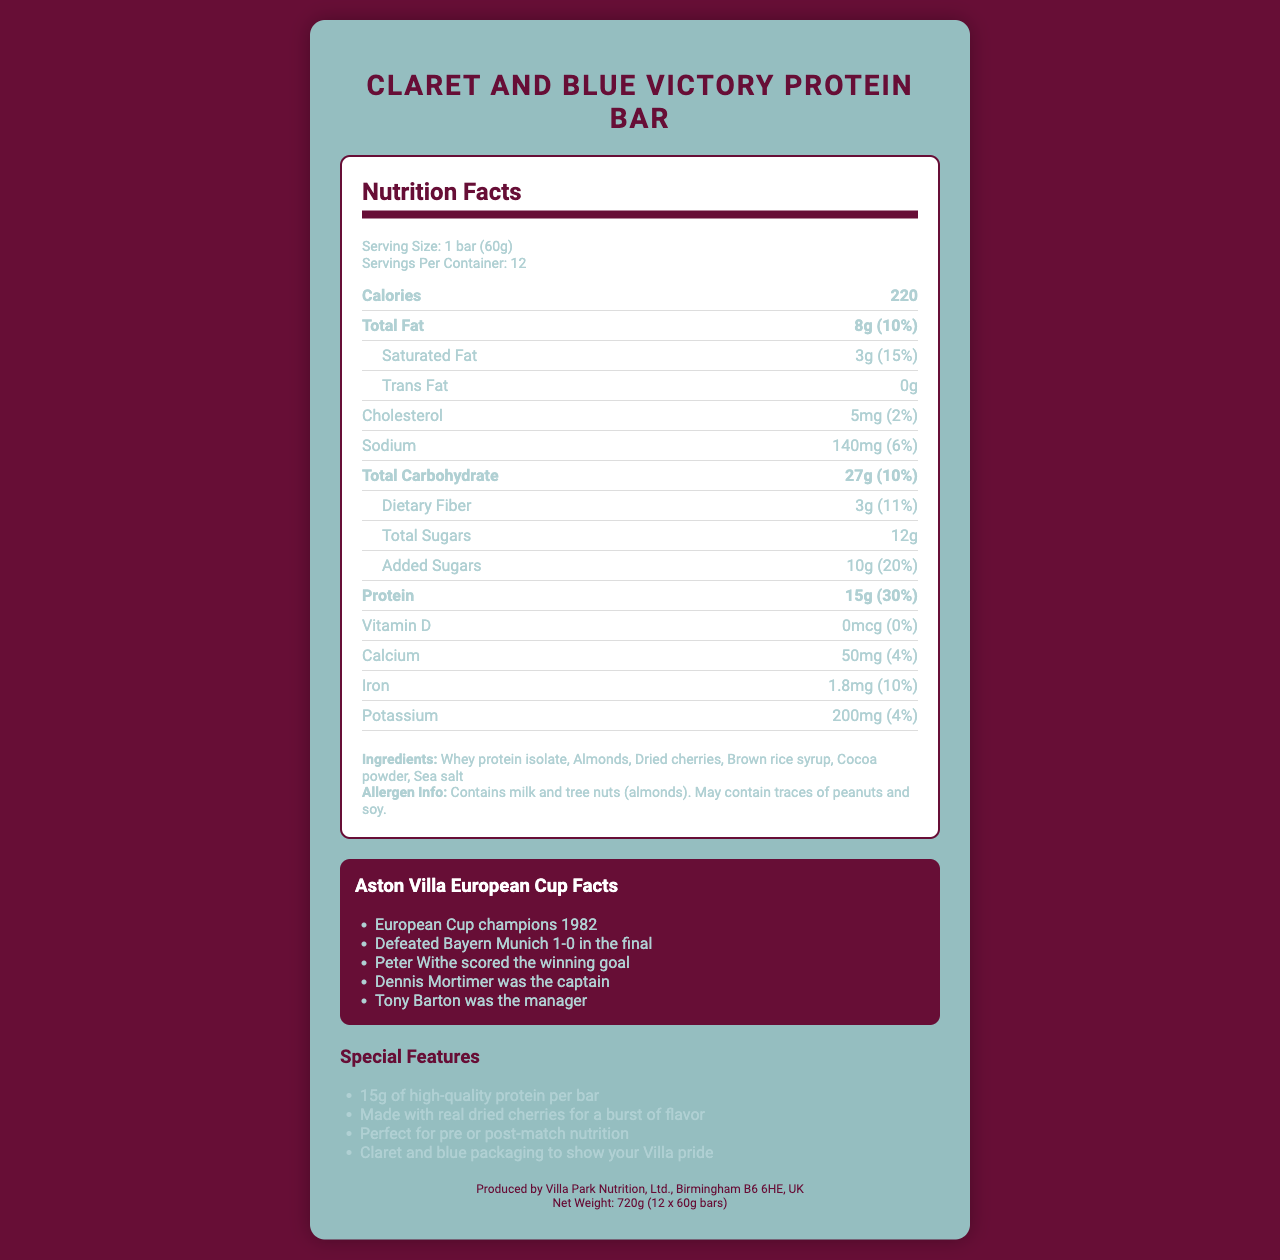what is the serving size of the Claret and Blue Victory Protein Bar? The serving size is stated directly in the document as "1 bar (60g)".
Answer: 1 bar (60g) how many calories are in one serving of the Claret and Blue Victory Protein Bar? The number of calories per serving is noted in the nutrition facts section, listed as "220".
Answer: 220 calories what are the ingredients in the Claret and Blue Victory Protein Bar? The ingredients are listed in the ingredients section.
Answer: Whey protein isolate, Almonds, Dried cherries, Brown rice syrup, Cocoa powder, Sea salt how much protein does each Claret and Blue Victory Protein Bar contain? The amount of protein per serving is given in the nutrition facts section as "15g".
Answer: 15g what allergens are present in the Claret and Blue Victory Protein Bar? The allergen information is provided in a specific section labeled "Allergen Info".
Answer: Contains milk and tree nuts (almonds). May contain traces of peanuts and soy. which year did Aston Villa win the European Cup? The document includes a section titled "Aston Villa European Cup Facts" that states the year of the victory as "1982".
Answer: 1982 how much sodium is in a serving of the Claret and Blue Victory Protein Bar? The sodium content per serving is listed as "140mg" within the nutrition facts section.
Answer: 140mg how does the Claret and Blue Victory Protein Bar relate to Aston Villa Football Club? A. It has the club's emblem on the packaging. B. It contains facts about the club's European Cup win. C. It is produced in Villa Park Stadium. D. None of the above. The document mentions that it contains "Aston Villa European Cup Facts", specifically highlighting the club's 1982 victory.
Answer: B what type of manager was Tony Barton in the context of Aston Villa? A. Goalkeeping Coach B. General Manager C. Fitness Coach D. Manager during the European Cup win The document lists "Tony Barton was the manager" under the Aston Villa European Cup facts.
Answer: D is the Claret and Blue Victory Protein Bar suitable for people with peanut allergies? The allergen info states that it "May contain traces of peanuts," indicating it might not be safe for those with peanut allergies.
Answer: No what is the main idea of the document? This summary explains the overall content and purpose of the document.
Answer: The document provides comprehensive details about the Claret and Blue Victory Protein Bar, including nutrition facts, ingredients, allergen information, Aston Villa European Cup facts, special features, and manufacturer info. what team did Aston Villa defeat in the final to win the European Cup? The document states that Aston Villa "Defeated Bayern Munich 1-0 in the final" under the Aston Villa European Cup facts.
Answer: Bayern Munich how many servings are in one container of Claret and Blue Victory Protein Bars? The document lists the number of servings per container as "12".
Answer: 12 servings who scored the winning goal for Aston Villa in the European Cup final? The document states "Peter Withe scored the winning goal" in the European Cup facts section.
Answer: Peter Withe what’s the net weight of the Claret and Blue Victory Protein Bars package? The net weight is specified as "720g (12 x 60g bars)" in the manufacturer info section.
Answer: 720g can I determine the daily recommended intake of protein from this document? The document provides the protein content per serving as a percentage of daily value, but does not state the total daily recommended intake explicitly.
Answer: Not enough information how much iron does the Claret and Blue Victory Protein Bar provide per serving? The document states the iron content per serving as "1.8mg" under the nutrition facts section.
Answer: 1.8mg is there any vitamin D in the Claret and Blue Victory Protein Bar? The document lists vitamin D content as "0mcg (0%)", indicating that the bar does not contain any vitamin D.
Answer: No 